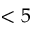Convert formula to latex. <formula><loc_0><loc_0><loc_500><loc_500>< 5</formula> 